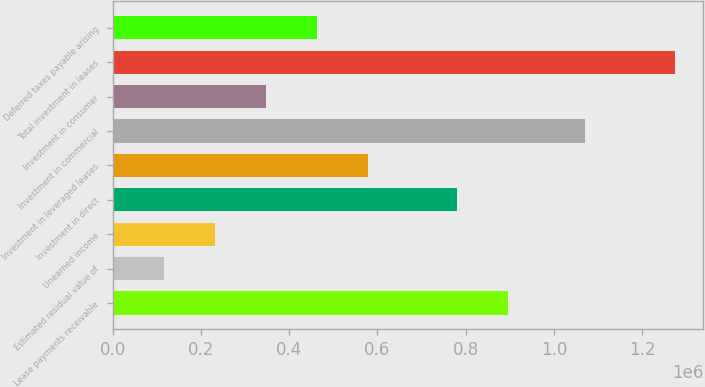Convert chart. <chart><loc_0><loc_0><loc_500><loc_500><bar_chart><fcel>Lease payments receivable<fcel>Estimated residual value of<fcel>Unearned income<fcel>Investment in direct<fcel>Investment in leveraged leases<fcel>Investment in commercial<fcel>Investment in consumer<fcel>Total investment in leases<fcel>Deferred taxes payable arising<nl><fcel>896959<fcel>115114<fcel>231062<fcel>781011<fcel>578906<fcel>1.06971e+06<fcel>347010<fcel>1.2746e+06<fcel>462958<nl></chart> 